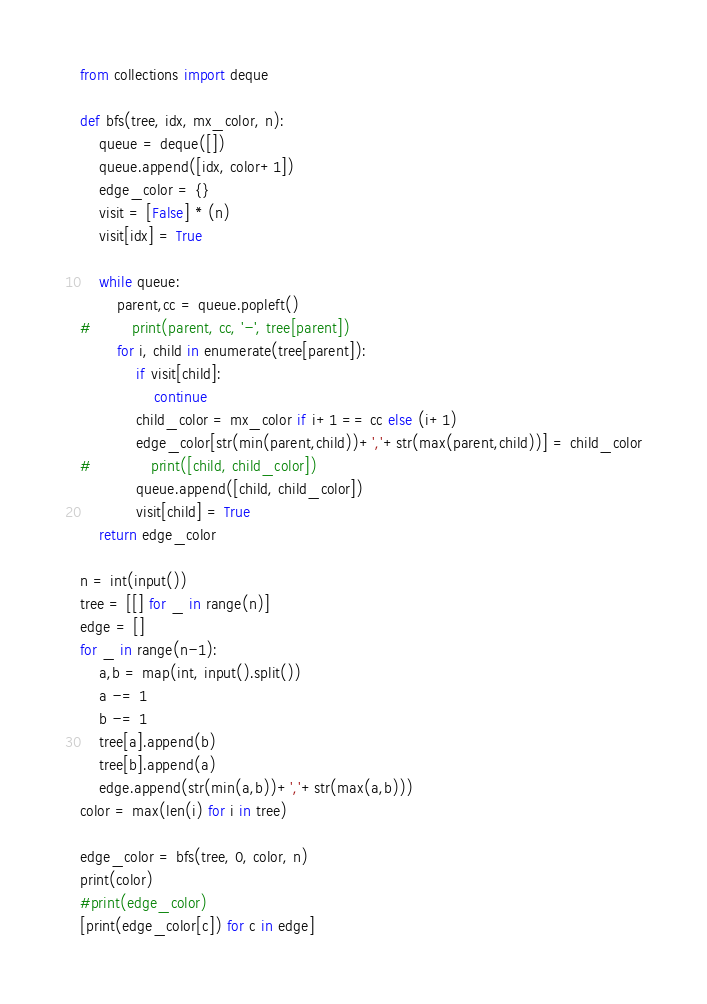Convert code to text. <code><loc_0><loc_0><loc_500><loc_500><_Python_>from collections import deque

def bfs(tree, idx, mx_color, n):
    queue = deque([])
    queue.append([idx, color+1])
    edge_color = {}
    visit = [False] * (n)
    visit[idx] = True

    while queue:
        parent,cc = queue.popleft()
#         print(parent, cc, '-', tree[parent])
        for i, child in enumerate(tree[parent]):
            if visit[child]:
                continue
            child_color = mx_color if i+1 == cc else (i+1)
            edge_color[str(min(parent,child))+','+str(max(parent,child))] = child_color
#             print([child, child_color])
            queue.append([child, child_color])
            visit[child] = True
    return edge_color

n = int(input())
tree = [[] for _ in range(n)]
edge = []
for _ in range(n-1):
    a,b = map(int, input().split())
    a -= 1
    b -= 1
    tree[a].append(b)
    tree[b].append(a)
    edge.append(str(min(a,b))+','+str(max(a,b)))
color = max(len(i) for i in tree)

edge_color = bfs(tree, 0, color, n)
print(color)
#print(edge_color)
[print(edge_color[c]) for c in edge]</code> 